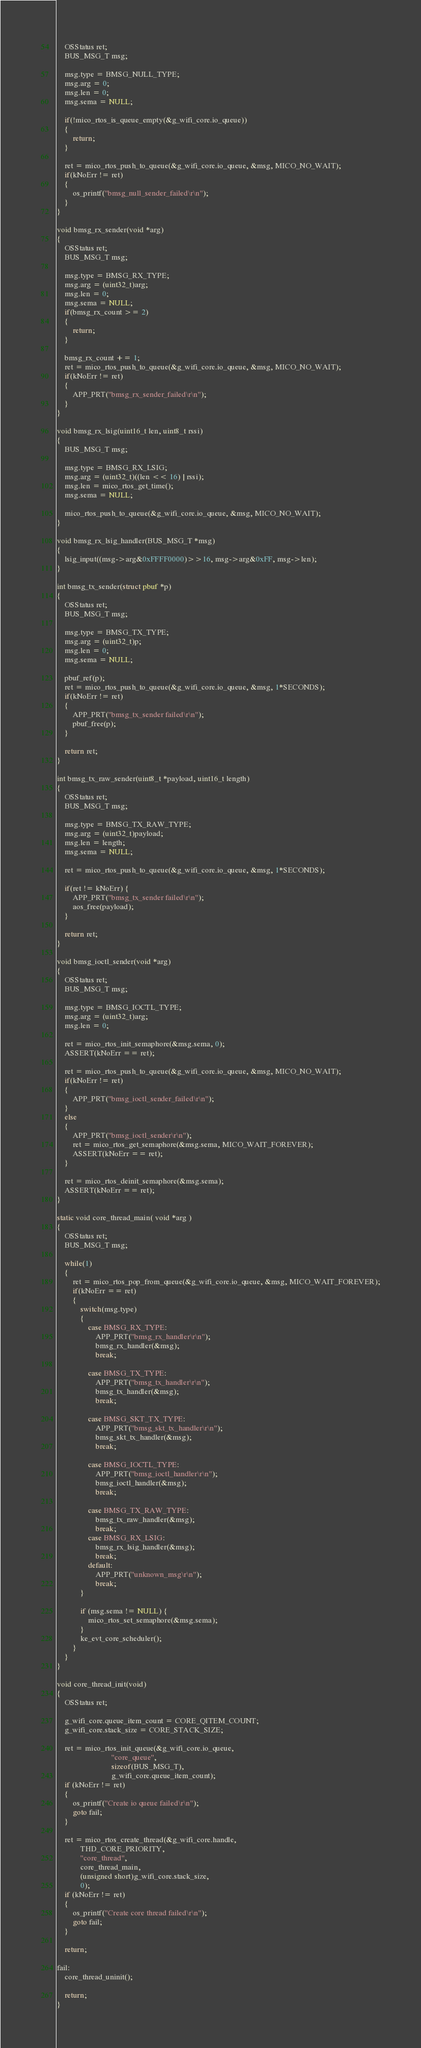<code> <loc_0><loc_0><loc_500><loc_500><_C_>	OSStatus ret;
	BUS_MSG_T msg;

	msg.type = BMSG_NULL_TYPE;
	msg.arg = 0;
	msg.len = 0;
	msg.sema = NULL;
	
	if(!mico_rtos_is_queue_empty(&g_wifi_core.io_queue))
	{
		return;
	}
	
	ret = mico_rtos_push_to_queue(&g_wifi_core.io_queue, &msg, MICO_NO_WAIT);
	if(kNoErr != ret)
	{
		os_printf("bmsg_null_sender_failed\r\n");
	}
}

void bmsg_rx_sender(void *arg)
{
	OSStatus ret;
	BUS_MSG_T msg;

	msg.type = BMSG_RX_TYPE;
	msg.arg = (uint32_t)arg;
	msg.len = 0;
	msg.sema = NULL;
	if(bmsg_rx_count >= 2)
	{
		return;
	}
	
	bmsg_rx_count += 1;
	ret = mico_rtos_push_to_queue(&g_wifi_core.io_queue, &msg, MICO_NO_WAIT);
	if(kNoErr != ret)
	{
		APP_PRT("bmsg_rx_sender_failed\r\n");
	}
}

void bmsg_rx_lsig(uint16_t len, uint8_t rssi)
{
	BUS_MSG_T msg;

	msg.type = BMSG_RX_LSIG;
	msg.arg = (uint32_t)((len << 16) | rssi);
	msg.len = mico_rtos_get_time();
	msg.sema = NULL;

	mico_rtos_push_to_queue(&g_wifi_core.io_queue, &msg, MICO_NO_WAIT);
}

void bmsg_rx_lsig_handler(BUS_MSG_T *msg)
{
	lsig_input((msg->arg&0xFFFF0000)>>16, msg->arg&0xFF, msg->len);
}

int bmsg_tx_sender(struct pbuf *p)
{
	OSStatus ret;
	BUS_MSG_T msg;

	msg.type = BMSG_TX_TYPE;
	msg.arg = (uint32_t)p;
	msg.len = 0;
	msg.sema = NULL;

	pbuf_ref(p);
	ret = mico_rtos_push_to_queue(&g_wifi_core.io_queue, &msg, 1*SECONDS);
	if(kNoErr != ret)
	{
		APP_PRT("bmsg_tx_sender failed\r\n");
		pbuf_free(p);
	} 

	return ret;
}

int bmsg_tx_raw_sender(uint8_t *payload, uint16_t length)
{
    OSStatus ret;
    BUS_MSG_T msg;

    msg.type = BMSG_TX_RAW_TYPE;
    msg.arg = (uint32_t)payload;
    msg.len = length;
    msg.sema = NULL;

    ret = mico_rtos_push_to_queue(&g_wifi_core.io_queue, &msg, 1*SECONDS);

    if(ret != kNoErr) {
        APP_PRT("bmsg_tx_sender failed\r\n");
        aos_free(payload);
    }

    return ret;
}

void bmsg_ioctl_sender(void *arg)
{
	OSStatus ret;
	BUS_MSG_T msg;

	msg.type = BMSG_IOCTL_TYPE;
	msg.arg = (uint32_t)arg;
	msg.len = 0;
	
    ret = mico_rtos_init_semaphore(&msg.sema, 0);
    ASSERT(kNoErr == ret);
	
	ret = mico_rtos_push_to_queue(&g_wifi_core.io_queue, &msg, MICO_NO_WAIT);
	if(kNoErr != ret)
	{
		APP_PRT("bmsg_ioctl_sender_failed\r\n");
	} 
	else 
	{
		APP_PRT("bmsg_ioctl_sender\r\n");
		ret = mico_rtos_get_semaphore(&msg.sema, MICO_WAIT_FOREVER);
		ASSERT(kNoErr == ret);     
	}

	ret = mico_rtos_deinit_semaphore(&msg.sema);
	ASSERT(kNoErr == ret);   
}

static void core_thread_main( void *arg )
{
    OSStatus ret;
	BUS_MSG_T msg;

    while(1)
    {	
        ret = mico_rtos_pop_from_queue(&g_wifi_core.io_queue, &msg, MICO_WAIT_FOREVER);
        if(kNoErr == ret)
        {
        	switch(msg.type)
        	{
        		case BMSG_RX_TYPE:
					APP_PRT("bmsg_rx_handler\r\n");
					bmsg_rx_handler(&msg);
					break;
					
        		case BMSG_TX_TYPE:
					APP_PRT("bmsg_tx_handler\r\n");
					bmsg_tx_handler(&msg);
					break;
					
        		case BMSG_SKT_TX_TYPE:
					APP_PRT("bmsg_skt_tx_handler\r\n");
					bmsg_skt_tx_handler(&msg);
					break;
					
        		case BMSG_IOCTL_TYPE:
					APP_PRT("bmsg_ioctl_handler\r\n");
					bmsg_ioctl_handler(&msg);
					break;
					
                case BMSG_TX_RAW_TYPE:
                    bmsg_tx_raw_handler(&msg);
                    break;
                case BMSG_RX_LSIG:
                    bmsg_rx_lsig_handler(&msg);
                    break;
        		default:
					APP_PRT("unknown_msg\r\n");
					break;
        	}

			if (msg.sema != NULL) {
				mico_rtos_set_semaphore(&msg.sema);
			}
			ke_evt_core_scheduler();
        }
    }
}

void core_thread_init(void)
{
	OSStatus ret;
	
	g_wifi_core.queue_item_count = CORE_QITEM_COUNT;
	g_wifi_core.stack_size = CORE_STACK_SIZE;
	
	ret = mico_rtos_init_queue(&g_wifi_core.io_queue, 
							"core_queue",
							sizeof(BUS_MSG_T),
							g_wifi_core.queue_item_count);
	if (kNoErr != ret) 
	{
		os_printf("Create io queue failed\r\n");
		goto fail;
	}

    ret = mico_rtos_create_thread(&g_wifi_core.handle, 
            THD_CORE_PRIORITY,
            "core_thread", 
            core_thread_main, 
            (unsigned short)g_wifi_core.stack_size, 
            0);
	if (kNoErr != ret) 
	{
		os_printf("Create core thread failed\r\n");
		goto fail;
	}
	
	return;
	
fail:
	core_thread_uninit();
	
	return;
}
</code> 